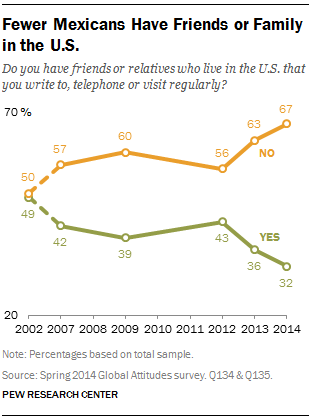Identify some key points in this picture. The value of green data points in 2014 was not 36. The median of all the green points below 40 is 36. 